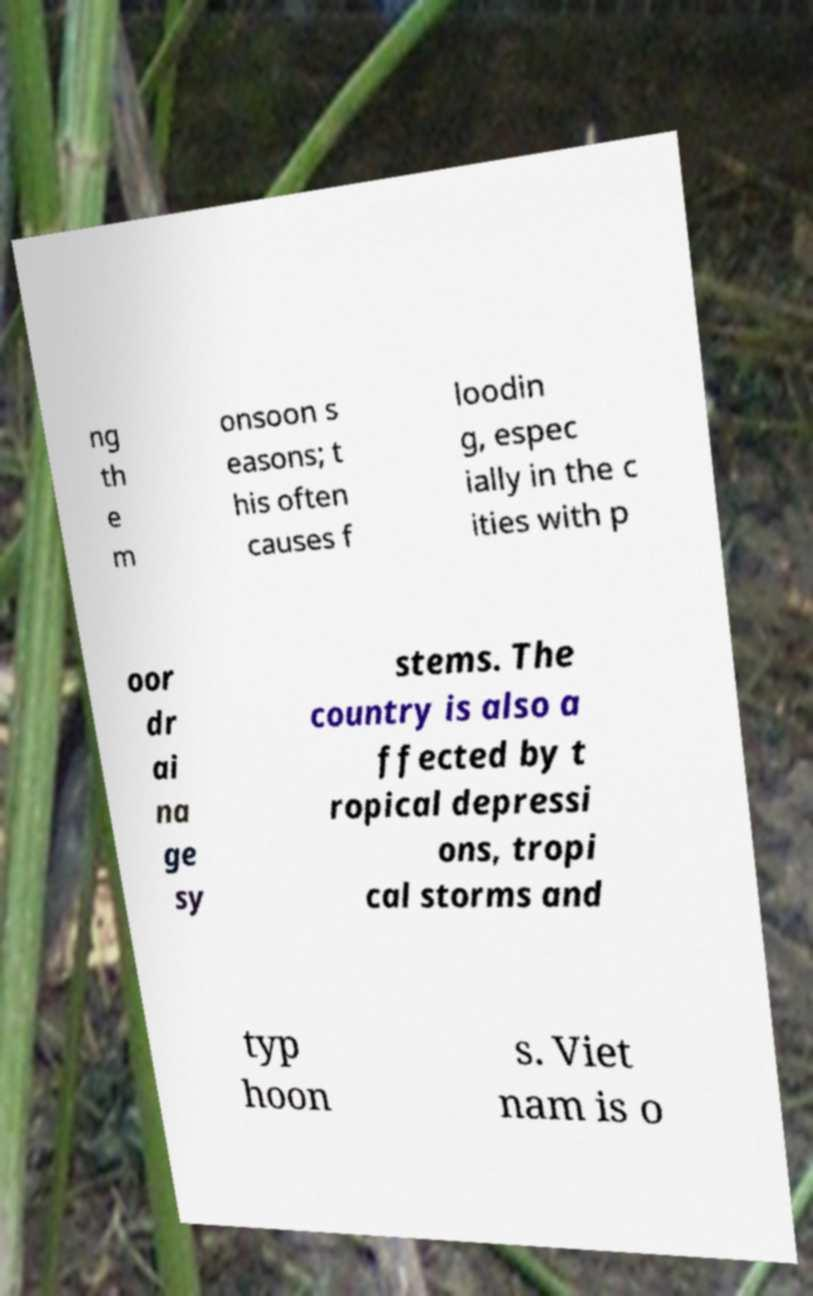I need the written content from this picture converted into text. Can you do that? ng th e m onsoon s easons; t his often causes f loodin g, espec ially in the c ities with p oor dr ai na ge sy stems. The country is also a ffected by t ropical depressi ons, tropi cal storms and typ hoon s. Viet nam is o 